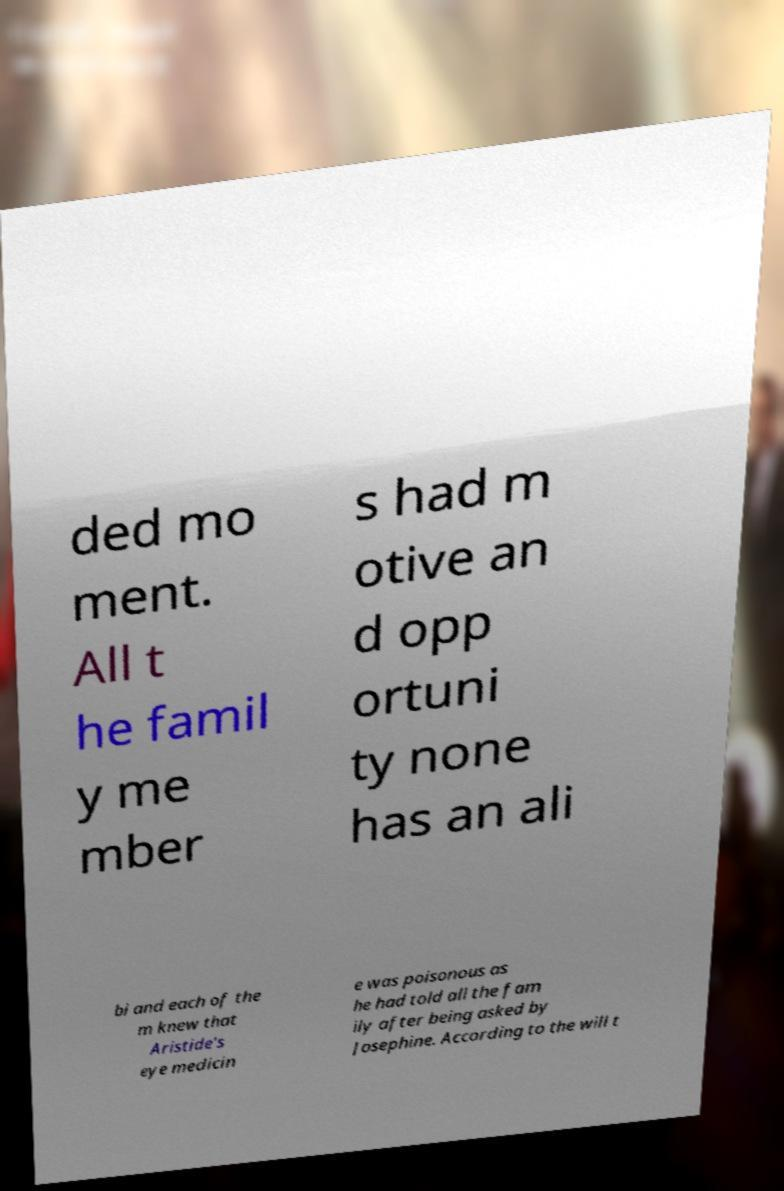Please read and relay the text visible in this image. What does it say? ded mo ment. All t he famil y me mber s had m otive an d opp ortuni ty none has an ali bi and each of the m knew that Aristide's eye medicin e was poisonous as he had told all the fam ily after being asked by Josephine. According to the will t 